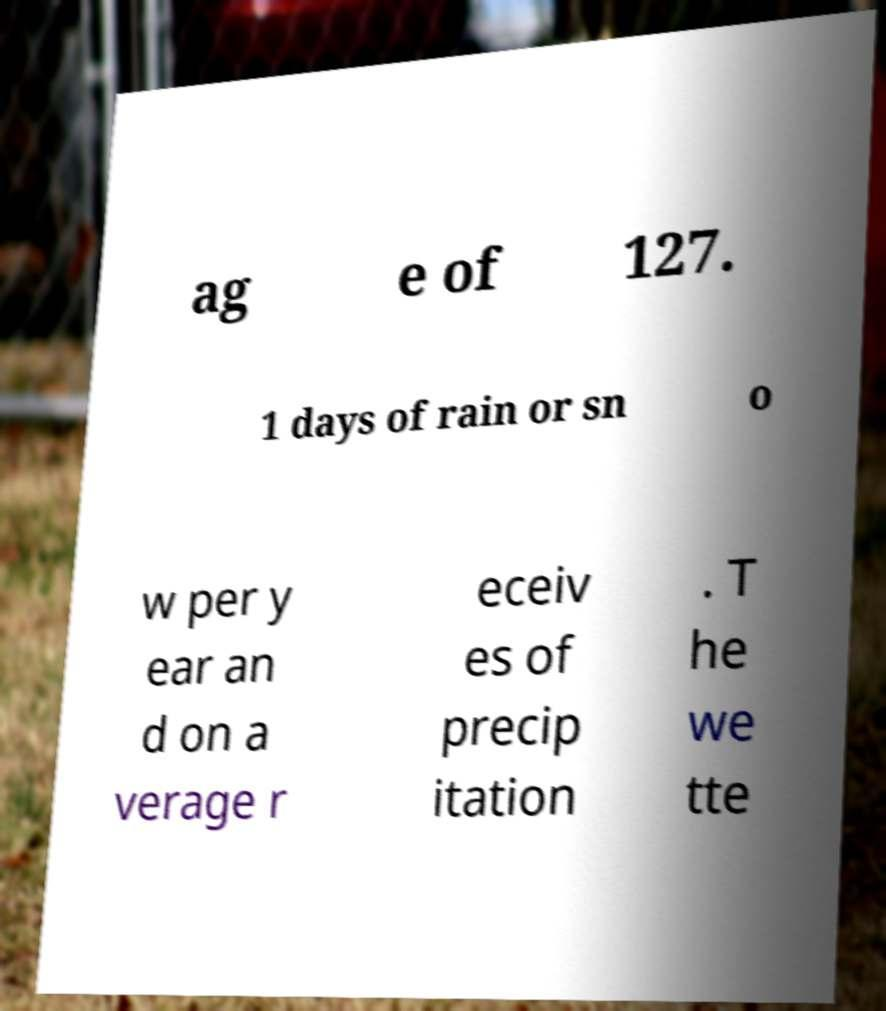There's text embedded in this image that I need extracted. Can you transcribe it verbatim? ag e of 127. 1 days of rain or sn o w per y ear an d on a verage r eceiv es of precip itation . T he we tte 